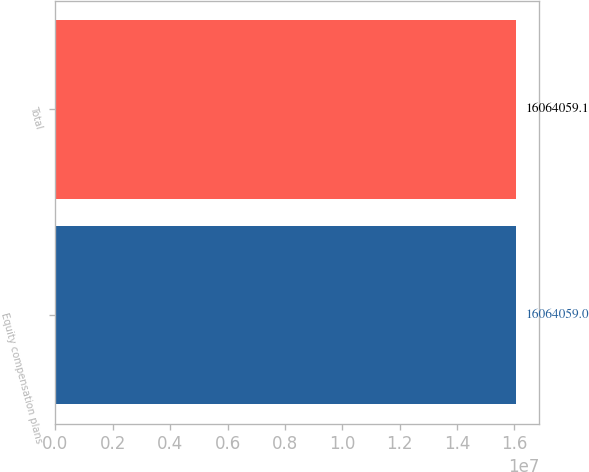Convert chart to OTSL. <chart><loc_0><loc_0><loc_500><loc_500><bar_chart><fcel>Equity compensation plans<fcel>Total<nl><fcel>1.60641e+07<fcel>1.60641e+07<nl></chart> 